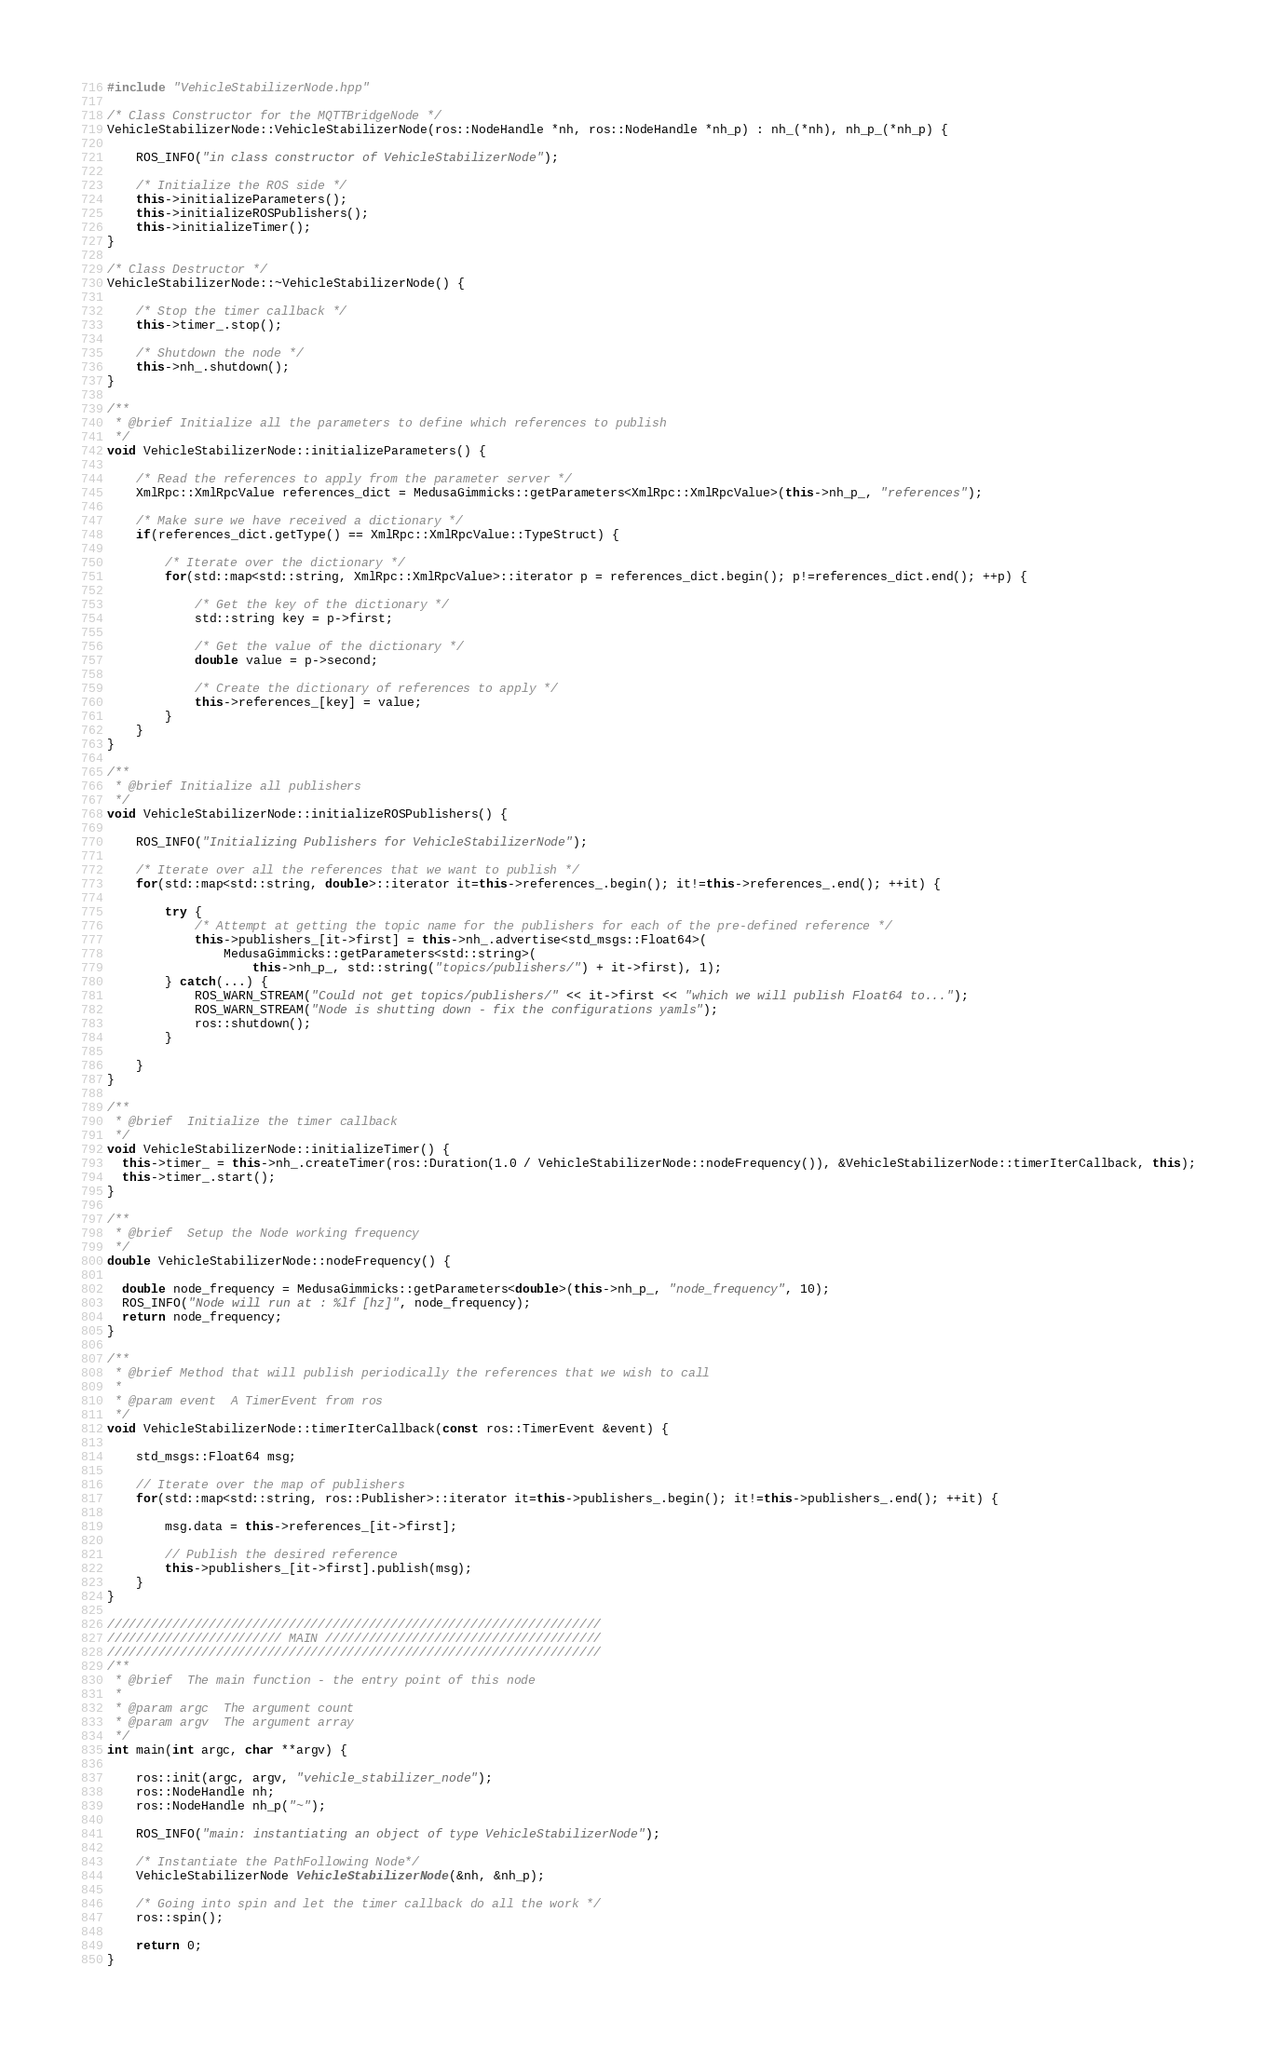Convert code to text. <code><loc_0><loc_0><loc_500><loc_500><_C++_>#include "VehicleStabilizerNode.hpp"

/* Class Constructor for the MQTTBridgeNode */
VehicleStabilizerNode::VehicleStabilizerNode(ros::NodeHandle *nh, ros::NodeHandle *nh_p) : nh_(*nh), nh_p_(*nh_p) {

    ROS_INFO("in class constructor of VehicleStabilizerNode");

    /* Initialize the ROS side */
    this->initializeParameters();
    this->initializeROSPublishers();
    this->initializeTimer();
}

/* Class Destructor */
VehicleStabilizerNode::~VehicleStabilizerNode() {

    /* Stop the timer callback */
    this->timer_.stop();

    /* Shutdown the node */
    this->nh_.shutdown();
}

/**
 * @brief Initialize all the parameters to define which references to publish
 */
void VehicleStabilizerNode::initializeParameters() {

    /* Read the references to apply from the parameter server */
    XmlRpc::XmlRpcValue references_dict = MedusaGimmicks::getParameters<XmlRpc::XmlRpcValue>(this->nh_p_, "references");

    /* Make sure we have received a dictionary */
    if(references_dict.getType() == XmlRpc::XmlRpcValue::TypeStruct) {

        /* Iterate over the dictionary */
        for(std::map<std::string, XmlRpc::XmlRpcValue>::iterator p = references_dict.begin(); p!=references_dict.end(); ++p) {
            
            /* Get the key of the dictionary */
            std::string key = p->first;

            /* Get the value of the dictionary */
            double value = p->second;

            /* Create the dictionary of references to apply */
            this->references_[key] = value;
        }
    }
}

/**
 * @brief Initialize all publishers
 */
void VehicleStabilizerNode::initializeROSPublishers() {

    ROS_INFO("Initializing Publishers for VehicleStabilizerNode");

    /* Iterate over all the references that we want to publish */
    for(std::map<std::string, double>::iterator it=this->references_.begin(); it!=this->references_.end(); ++it) {
        
        try {
            /* Attempt at getting the topic name for the publishers for each of the pre-defined reference */
            this->publishers_[it->first] = this->nh_.advertise<std_msgs::Float64>(
                MedusaGimmicks::getParameters<std::string>(
                    this->nh_p_, std::string("topics/publishers/") + it->first), 1);
        } catch(...) {
            ROS_WARN_STREAM("Could not get topics/publishers/" << it->first << "which we will publish Float64 to...");
            ROS_WARN_STREAM("Node is shutting down - fix the configurations yamls");
            ros::shutdown();
        }
        
    }
}

/**
 * @brief  Initialize the timer callback
 */
void VehicleStabilizerNode::initializeTimer() {
  this->timer_ = this->nh_.createTimer(ros::Duration(1.0 / VehicleStabilizerNode::nodeFrequency()), &VehicleStabilizerNode::timerIterCallback, this);
  this->timer_.start();
}

/**
 * @brief  Setup the Node working frequency
 */
double VehicleStabilizerNode::nodeFrequency() {

  double node_frequency = MedusaGimmicks::getParameters<double>(this->nh_p_, "node_frequency", 10);
  ROS_INFO("Node will run at : %lf [hz]", node_frequency);
  return node_frequency;
}

/**
 * @brief Method that will publish periodically the references that we wish to call
 *
 * @param event  A TimerEvent from ros
 */
void VehicleStabilizerNode::timerIterCallback(const ros::TimerEvent &event) {

    std_msgs::Float64 msg;

    // Iterate over the map of publishers
    for(std::map<std::string, ros::Publisher>::iterator it=this->publishers_.begin(); it!=this->publishers_.end(); ++it) {

        msg.data = this->references_[it->first];

        // Publish the desired reference
        this->publishers_[it->first].publish(msg);
    }
}

////////////////////////////////////////////////////////////////////
//////////////////////// MAIN //////////////////////////////////////
////////////////////////////////////////////////////////////////////
/**
 * @brief  The main function - the entry point of this node
 *
 * @param argc  The argument count
 * @param argv  The argument array
 */
int main(int argc, char **argv) {

    ros::init(argc, argv, "vehicle_stabilizer_node");
    ros::NodeHandle nh;
    ros::NodeHandle nh_p("~");

    ROS_INFO("main: instantiating an object of type VehicleStabilizerNode");

    /* Instantiate the PathFollowing Node*/
    VehicleStabilizerNode VehicleStabilizerNode(&nh, &nh_p);

    /* Going into spin and let the timer callback do all the work */
    ros::spin();

    return 0;
}</code> 